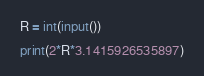Convert code to text. <code><loc_0><loc_0><loc_500><loc_500><_Python_>R = int(input())

print(2*R*3.1415926535897)</code> 